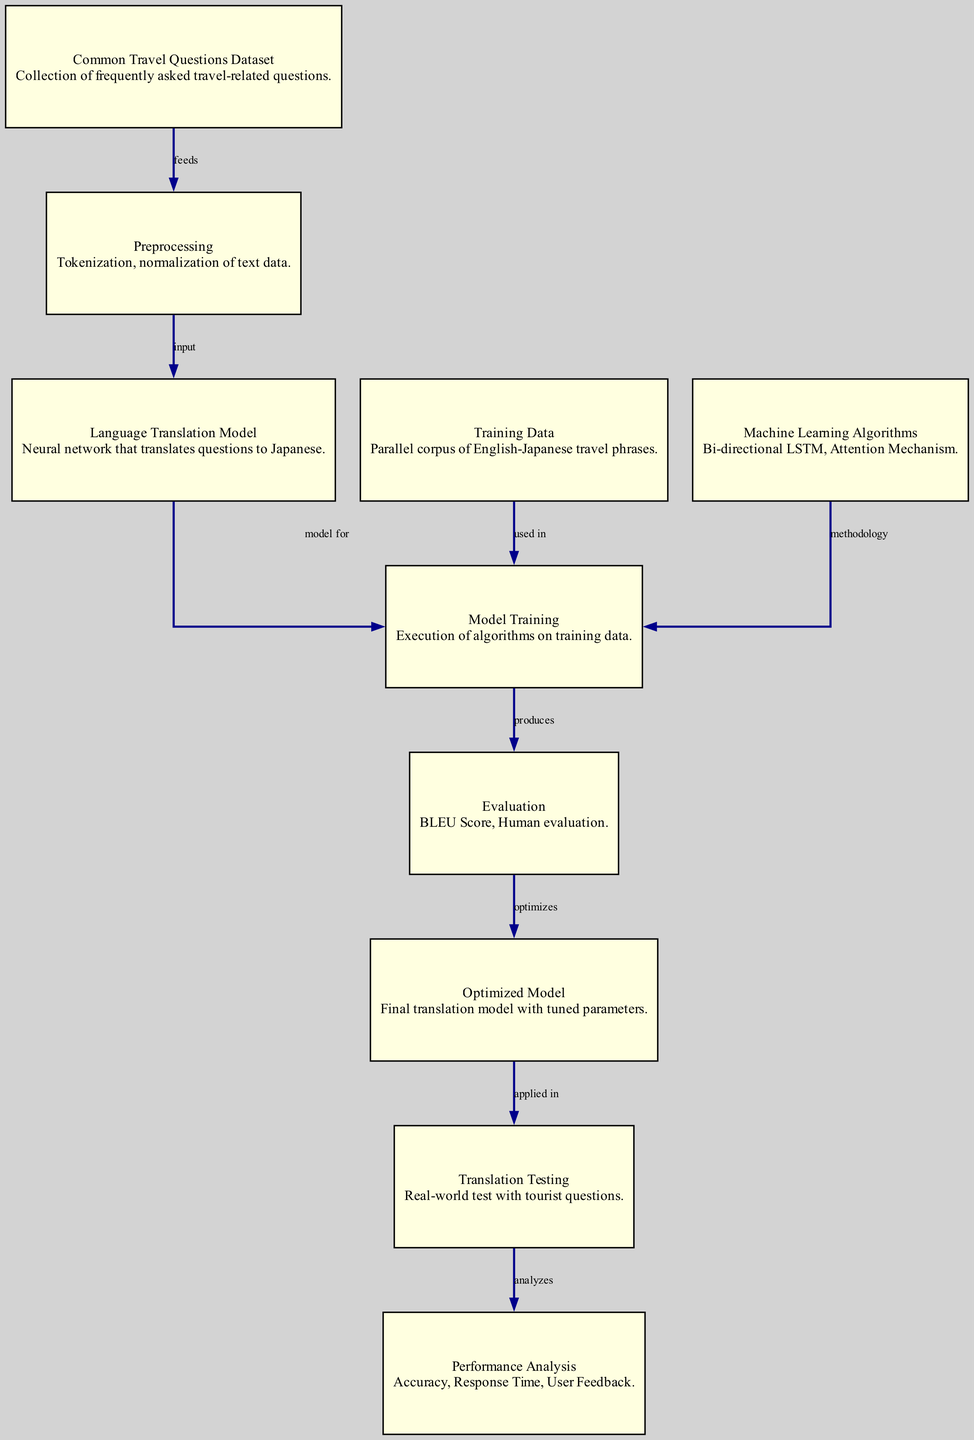What is the main purpose of the nodes in this diagram? The nodes represent different stages in the language translation process, starting from the dataset of common travel questions to the final performance analysis. Each node has a specific role that contributes to the overall translation model development and evaluation.
Answer: stages in language translation How many nodes are present in the diagram? By counting the distinct entries under the "nodes" section, we find there are ten nodes representing various components involved in the language translation analysis.
Answer: ten What is the relationship between "Training Data" and "Model Training"? The edge labeled "used in" indicates that "Training Data" provides the necessary data required for "Model Training" to take place, meaning that without the training data, the model cannot be trained.
Answer: used in Which node is directly responsible for producing evaluation metrics? The "Evaluation" node receives outputs from "Model Training" and is responsible for producing evaluation metrics like the BLEU Score and human evaluation feedback, indicating its role in quality assessment.
Answer: Evaluation What processes occur between "Optimized Model" and "Translation Testing"? The edge labeled "applied in" signifies that the optimized model, which has tuned parameters, is used during the translation testing phase, suggesting that this model is necessary for performing real-world translations.
Answer: applied in What is the first step in the diagram's process flow? The first step is represented by the "Common Travel Questions Dataset" node, which acts as the initial source of data that feeds into the preprocessing stage.
Answer: Common Travel Questions Dataset Which machine learning methodologies are indicated in the diagram? The methodologies are represented under the "Machine Learning Algorithms" node, specifically mentioning "Bi-directional LSTM" and "Attention Mechanism" as techniques used in model training.
Answer: Bi-directional LSTM, Attention Mechanism How does the diagram show the flow of information from preprocessing to model training? The edge labeled "input" connects the "Preprocessing" node to the "Language Translation Model" node, indicating that the output from preprocessing directly serves as input for model training.
Answer: input What is analyzed after "Translation Testing"? Following "Translation Testing," the node labeled "Performance Analysis" indicates that the results and outcomes from the translation tests are further analyzed for accuracy, response time, and user feedback.
Answer: Performance Analysis 